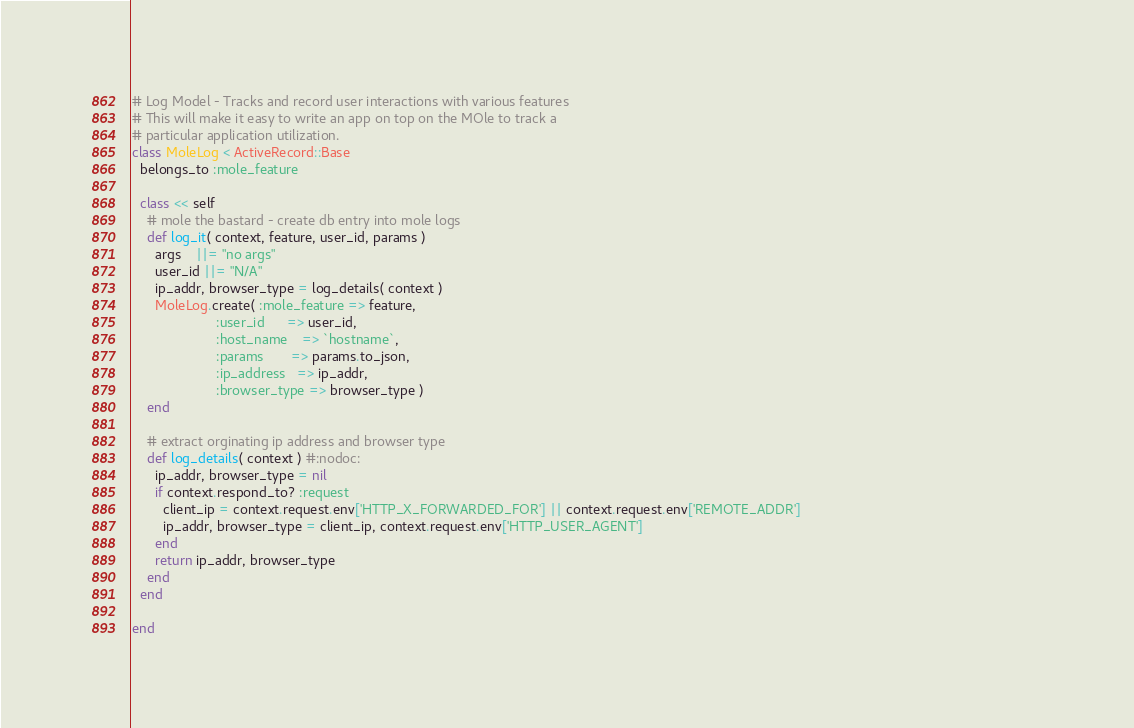Convert code to text. <code><loc_0><loc_0><loc_500><loc_500><_Ruby_># Log Model - Tracks and record user interactions with various features
# This will make it easy to write an app on top on the MOle to track a 
# particular application utilization.                     
class MoleLog < ActiveRecord::Base                                             
  belongs_to :mole_feature  
    
  class << self                                               
    # mole the bastard - create db entry into mole logs
    def log_it( context, feature, user_id, params )
      args    ||= "no args"                           
      user_id ||= "N/A"             
      ip_addr, browser_type = log_details( context )      
      MoleLog.create( :mole_feature => feature, 
                      :user_id      => user_id, 
                      :host_name    => `hostname`,
                      :params       => params.to_json,
                      :ip_address   => ip_addr, 
                      :browser_type => browser_type )
    end               
    
    # extract orginating ip address and browser type                                               
    def log_details( context ) #:nodoc:
      ip_addr, browser_type = nil
      if context.respond_to? :request      
        client_ip = context.request.env['HTTP_X_FORWARDED_FOR'] || context.request.env['REMOTE_ADDR']                                                               
        ip_addr, browser_type = client_ip, context.request.env['HTTP_USER_AGENT'] 
      end
      return ip_addr, browser_type
    end            
  end          
  
end</code> 